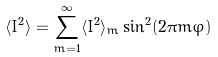Convert formula to latex. <formula><loc_0><loc_0><loc_500><loc_500>\langle I ^ { 2 } \rangle = \sum _ { m = 1 } ^ { \infty } \langle I ^ { 2 } \rangle _ { m } \sin ^ { 2 } ( 2 \pi m \varphi )</formula> 